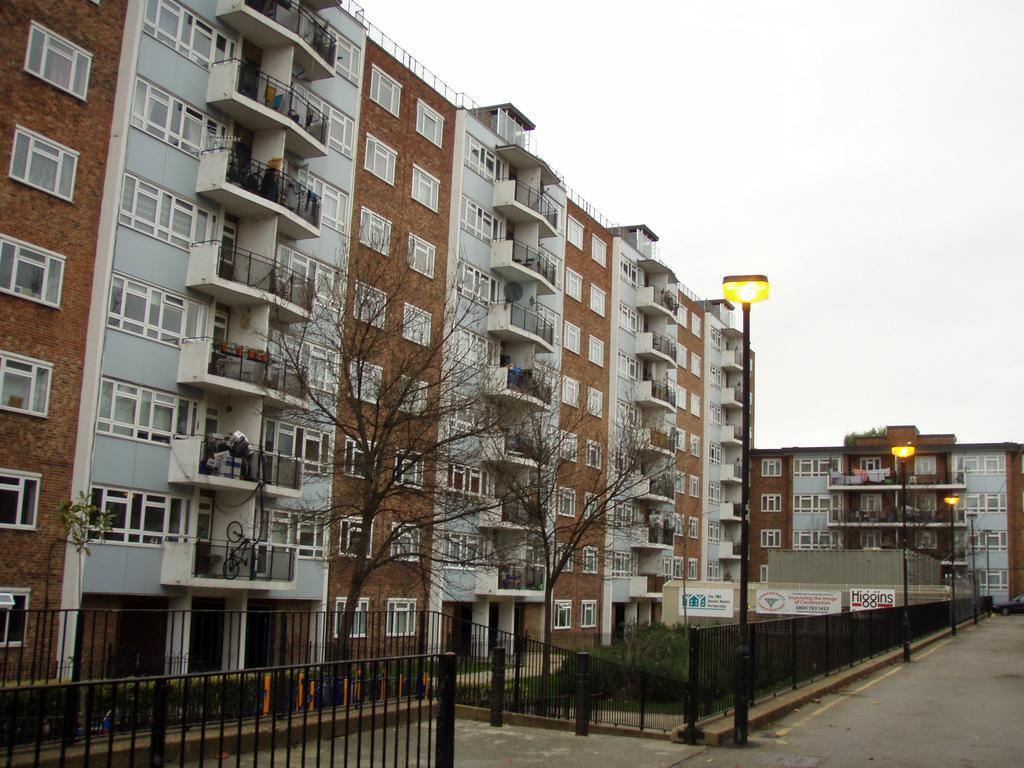What is located in the center of the image? There are buildings, trees, street lights, fencing, and plants in the center of the image. Can you describe the elements in the center of the image? The center of the image features buildings, trees, street lights, fencing, and plants. What can be seen in the background of the image? The sky is visible in the background of the image. What is the rate of the notebook in the image? There is no notebook present in the image, so it is not possible to determine its rate. Is there a battle taking place in the image? There is no indication of a battle in the image; it features buildings, trees, street lights, fencing, plants, and the sky. 